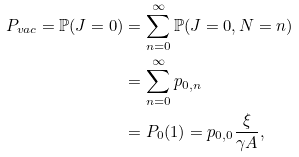Convert formula to latex. <formula><loc_0><loc_0><loc_500><loc_500>P _ { v a c } = \mathbb { P } ( J = 0 ) & = \sum _ { n = 0 } ^ { \infty } \mathbb { P } ( J = 0 , N = n ) \\ & = \sum _ { n = 0 } ^ { \infty } p _ { 0 , n } \\ & = P _ { 0 } ( 1 ) = p _ { 0 , 0 } \frac { \xi } { \gamma A } ,</formula> 